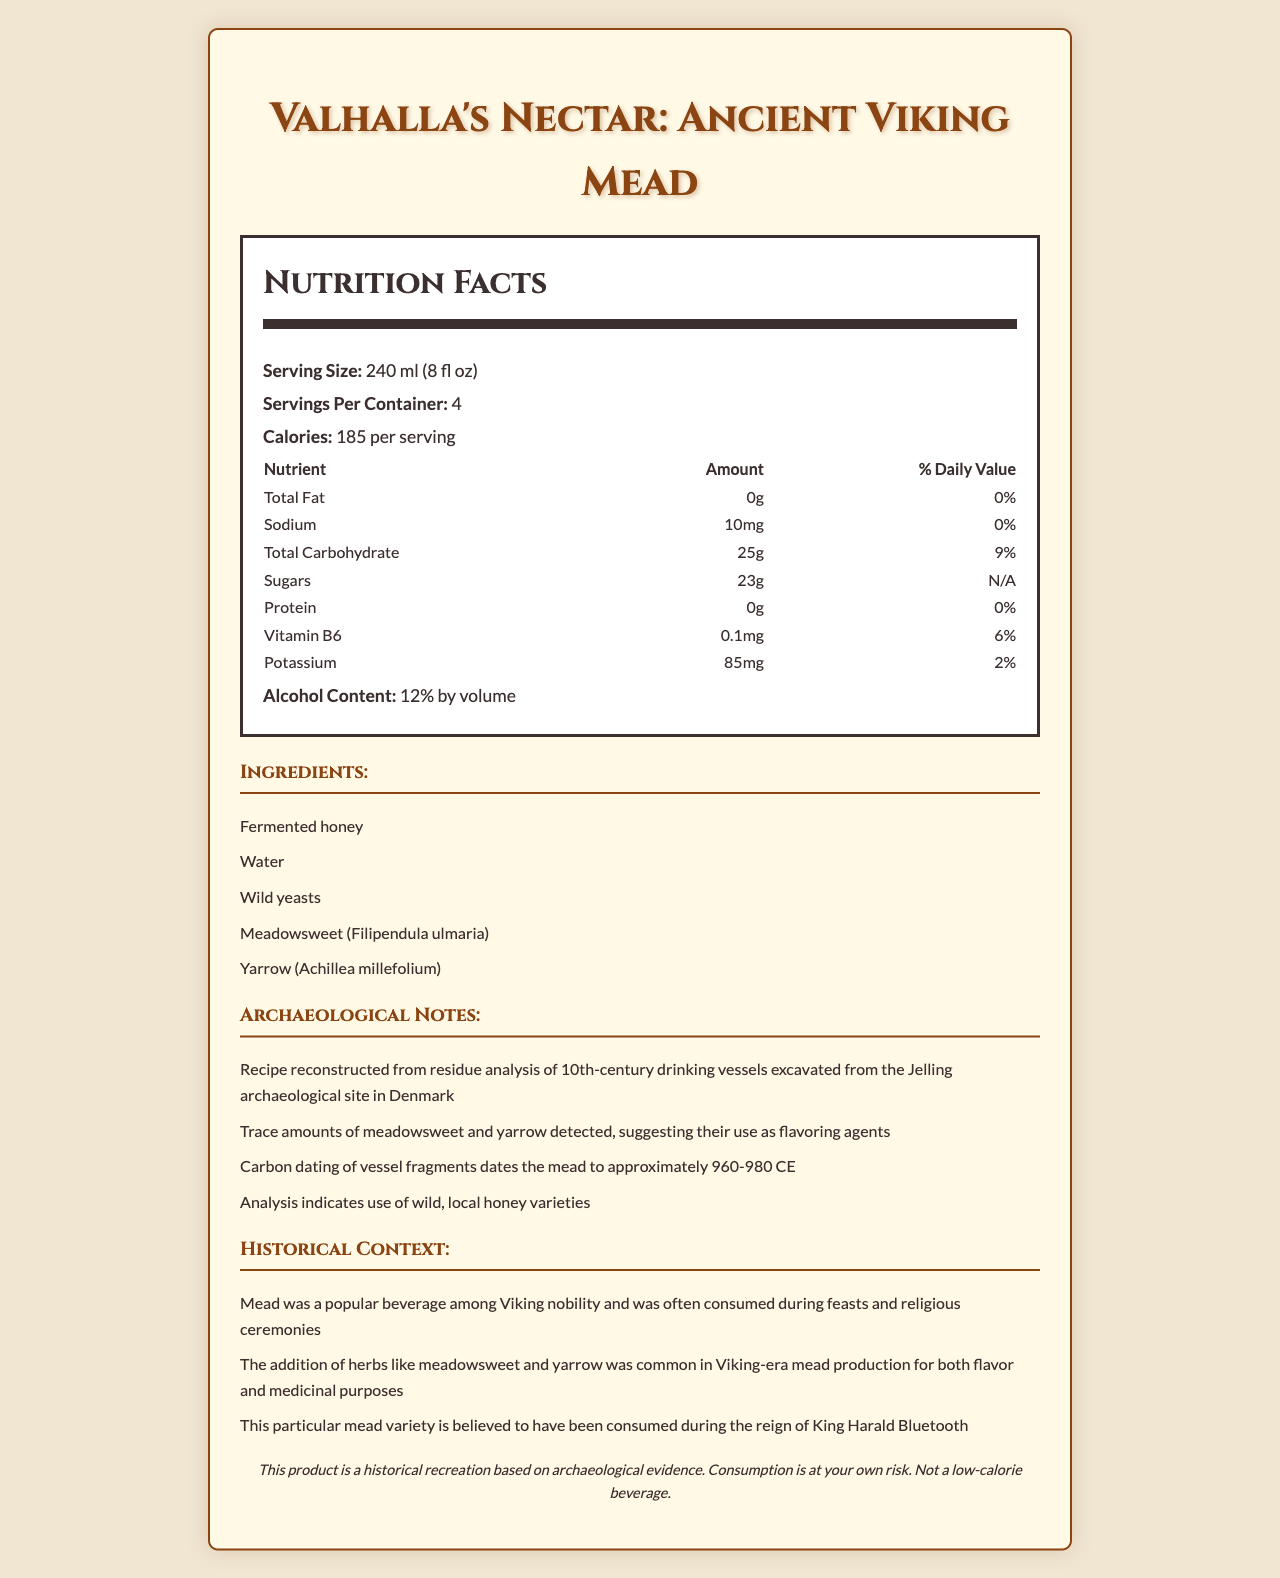what is the serving size? The serving size is explicitly mentioned as "240 ml (8 fl oz)" in the document.
Answer: 240 ml (8 fl oz) how many calories are there per serving? The nutrition label states that there are 185 calories per serving.
Answer: 185 calories which nutrient has the highest daily value percentage? The daily value percentage for Total Carbohydrate is 9%, which is the highest among the listed nutrients.
Answer: Total Carbohydrate what is the alcohol content by volume? The alcohol content is specified as "12% by volume" in the document.
Answer: 12% what main ingredients were used in this Viking mead? The ingredients list mentions "Fermented honey, Water, Wild yeasts, Meadowsweet (Filipendula ulmaria), Yarrow (Achillea millefolium)".
Answer: Fermented honey, water, wild yeasts, meadowsweet, and yarrow how many servings are there per container? A. 2 B. 4 C. 6 D. 8 The document specifies that there are 4 servings per container.
Answer: B which vitamin is present in this mead? A. Vitamin A B. Vitamin B6 C. Vitamin C D. Vitamin D The nutrition label lists Vitamin B6 at 0.1mg, which is 6% of the daily value.
Answer: B is this mead low in sodium? Yes/No The sodium content is only 10mg per serving, which accounts for 0% of the daily value, indicating it is low in sodium.
Answer: Yes summarize the key features and historical context of Valhalla's Nectar: Ancient Viking Mead. The document provides detailed nutritional information, ingredient lists, and archaeological and historical context, highlighting the mead's connections to Viking nobility, feasts, and medicinal practices.
Answer: Valhalla's Nectar: Ancient Viking Mead is a historical recreation based on residue analysis of 10th-century drinking vessels found in Denmark. It has a serving size of 240 ml, 4 servings per container, and contains 185 calories per serving. Key ingredients include fermented honey, water, wild yeasts, meadowsweet, and yarrow. It has 0g of fat, 10mg of sodium, 25g of carbohydrates (23g sugars), and no protein. It also contains Vitamin B6 and potassium. With an alcohol content of 12% by volume, the mead reflects Viking-era traditions and is believed to be consumed during the reign of King Harald Bluetooth. what kind and quantity of wild honey were used in the mead? The document only mentions the use of "wild, local honey varieties" but does not specify the kinds or quantities.
Answer: Cannot be determined 